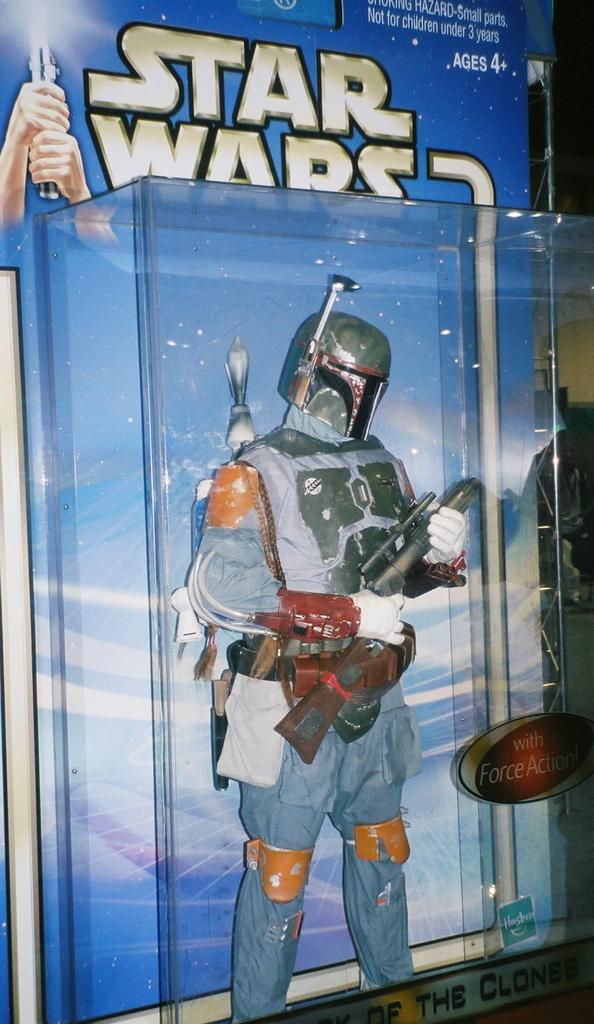<image>
Provide a brief description of the given image. Pictured is a stars wars toy still unopened in it's box. 